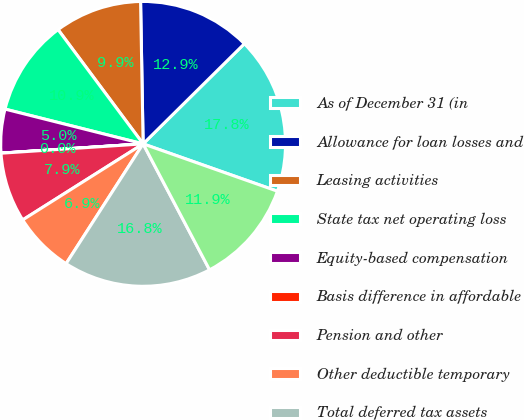Convert chart. <chart><loc_0><loc_0><loc_500><loc_500><pie_chart><fcel>As of December 31 (in<fcel>Allowance for loan losses and<fcel>Leasing activities<fcel>State tax net operating loss<fcel>Equity-based compensation<fcel>Basis difference in affordable<fcel>Pension and other<fcel>Other deductible temporary<fcel>Total deferred tax assets<fcel>Less valuation allowance for<nl><fcel>17.81%<fcel>12.87%<fcel>9.9%<fcel>10.89%<fcel>4.96%<fcel>0.01%<fcel>7.92%<fcel>6.94%<fcel>16.82%<fcel>11.88%<nl></chart> 